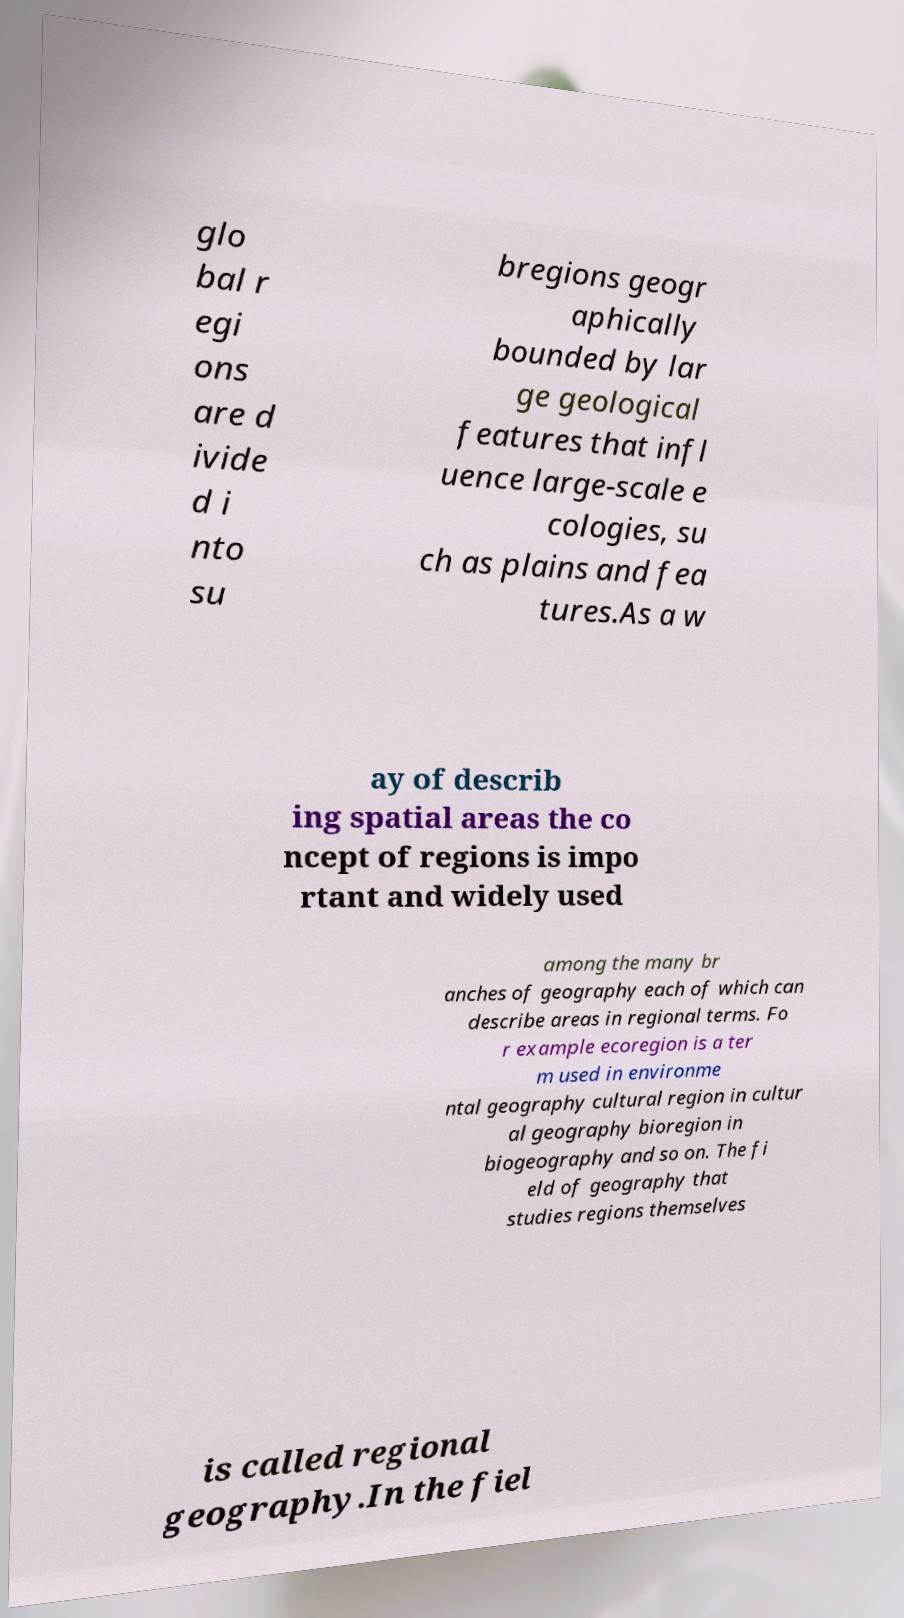Can you read and provide the text displayed in the image?This photo seems to have some interesting text. Can you extract and type it out for me? glo bal r egi ons are d ivide d i nto su bregions geogr aphically bounded by lar ge geological features that infl uence large-scale e cologies, su ch as plains and fea tures.As a w ay of describ ing spatial areas the co ncept of regions is impo rtant and widely used among the many br anches of geography each of which can describe areas in regional terms. Fo r example ecoregion is a ter m used in environme ntal geography cultural region in cultur al geography bioregion in biogeography and so on. The fi eld of geography that studies regions themselves is called regional geography.In the fiel 